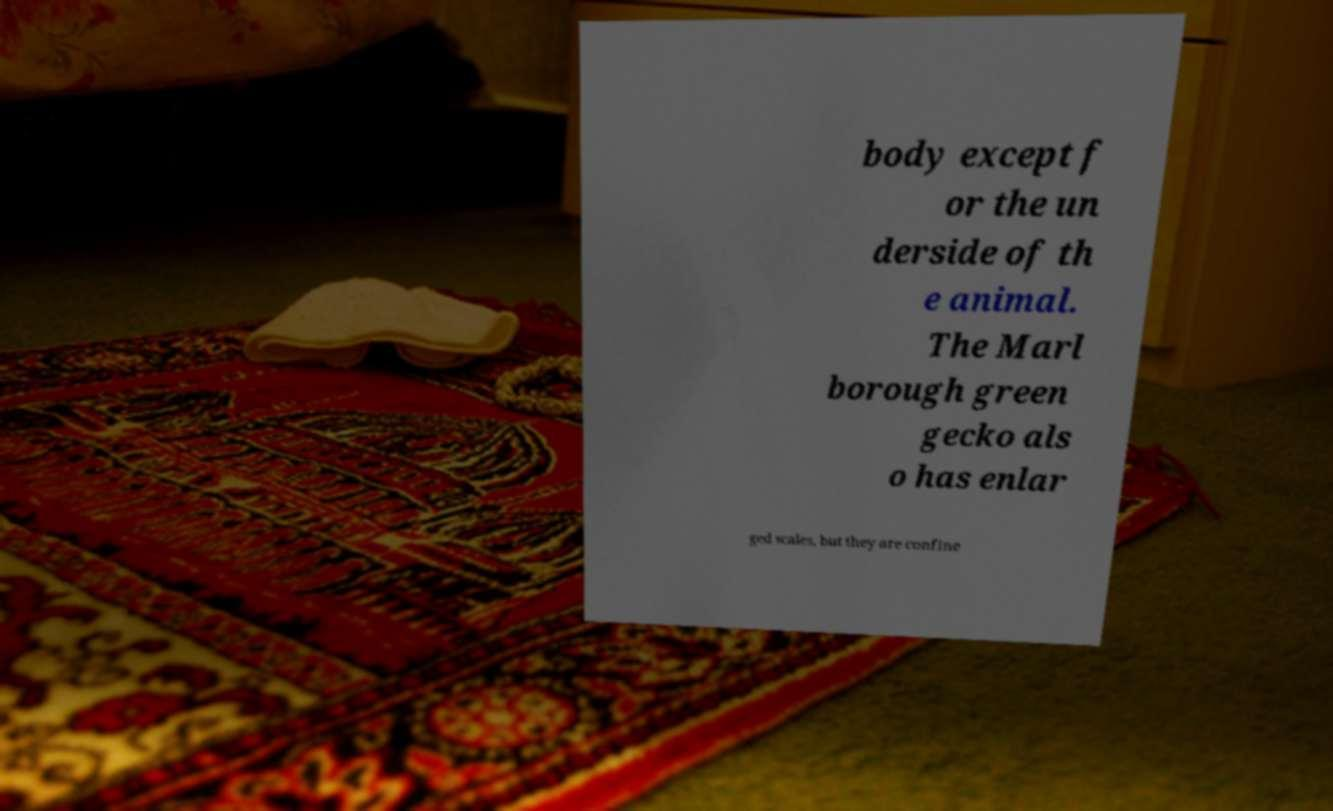Can you accurately transcribe the text from the provided image for me? body except f or the un derside of th e animal. The Marl borough green gecko als o has enlar ged scales, but they are confine 